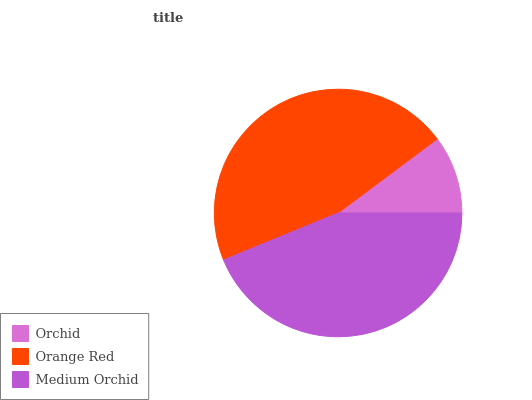Is Orchid the minimum?
Answer yes or no. Yes. Is Orange Red the maximum?
Answer yes or no. Yes. Is Medium Orchid the minimum?
Answer yes or no. No. Is Medium Orchid the maximum?
Answer yes or no. No. Is Orange Red greater than Medium Orchid?
Answer yes or no. Yes. Is Medium Orchid less than Orange Red?
Answer yes or no. Yes. Is Medium Orchid greater than Orange Red?
Answer yes or no. No. Is Orange Red less than Medium Orchid?
Answer yes or no. No. Is Medium Orchid the high median?
Answer yes or no. Yes. Is Medium Orchid the low median?
Answer yes or no. Yes. Is Orange Red the high median?
Answer yes or no. No. Is Orange Red the low median?
Answer yes or no. No. 